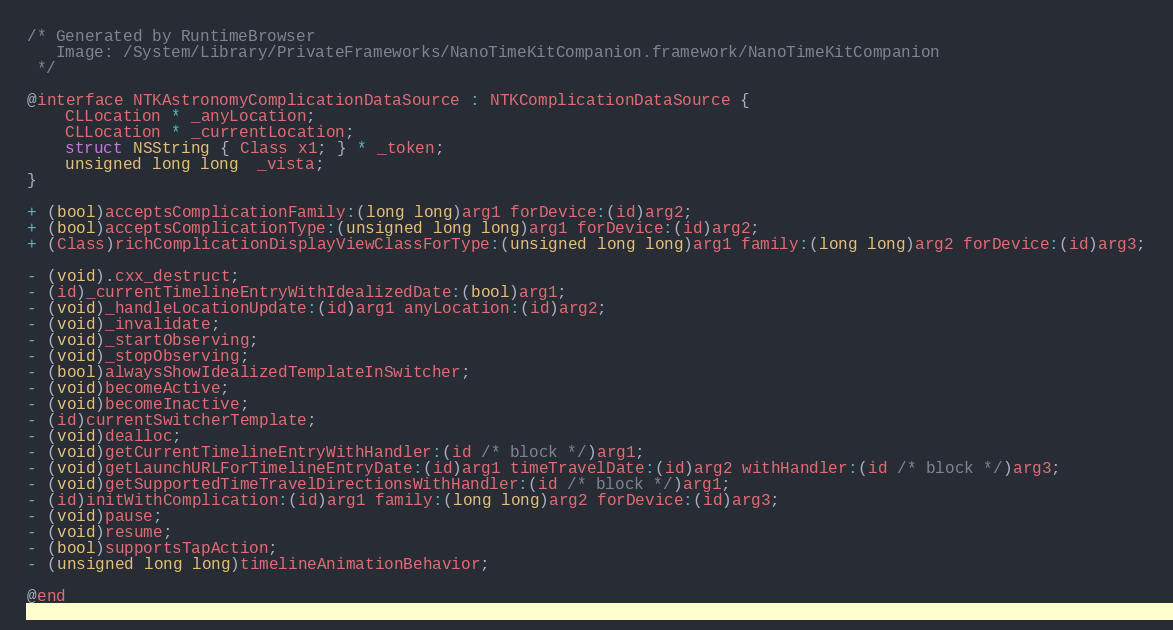Convert code to text. <code><loc_0><loc_0><loc_500><loc_500><_C_>/* Generated by RuntimeBrowser
   Image: /System/Library/PrivateFrameworks/NanoTimeKitCompanion.framework/NanoTimeKitCompanion
 */

@interface NTKAstronomyComplicationDataSource : NTKComplicationDataSource {
    CLLocation * _anyLocation;
    CLLocation * _currentLocation;
    struct NSString { Class x1; } * _token;
    unsigned long long  _vista;
}

+ (bool)acceptsComplicationFamily:(long long)arg1 forDevice:(id)arg2;
+ (bool)acceptsComplicationType:(unsigned long long)arg1 forDevice:(id)arg2;
+ (Class)richComplicationDisplayViewClassForType:(unsigned long long)arg1 family:(long long)arg2 forDevice:(id)arg3;

- (void).cxx_destruct;
- (id)_currentTimelineEntryWithIdealizedDate:(bool)arg1;
- (void)_handleLocationUpdate:(id)arg1 anyLocation:(id)arg2;
- (void)_invalidate;
- (void)_startObserving;
- (void)_stopObserving;
- (bool)alwaysShowIdealizedTemplateInSwitcher;
- (void)becomeActive;
- (void)becomeInactive;
- (id)currentSwitcherTemplate;
- (void)dealloc;
- (void)getCurrentTimelineEntryWithHandler:(id /* block */)arg1;
- (void)getLaunchURLForTimelineEntryDate:(id)arg1 timeTravelDate:(id)arg2 withHandler:(id /* block */)arg3;
- (void)getSupportedTimeTravelDirectionsWithHandler:(id /* block */)arg1;
- (id)initWithComplication:(id)arg1 family:(long long)arg2 forDevice:(id)arg3;
- (void)pause;
- (void)resume;
- (bool)supportsTapAction;
- (unsigned long long)timelineAnimationBehavior;

@end
</code> 